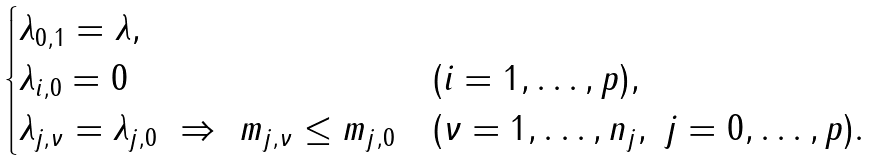Convert formula to latex. <formula><loc_0><loc_0><loc_500><loc_500>\begin{cases} \lambda _ { 0 , 1 } = \lambda , \\ \lambda _ { i , 0 } = 0 & ( i = 1 , \dots , p ) , \\ \lambda _ { j , \nu } = \lambda _ { j , 0 } \ \Rightarrow \ m _ { j , \nu } \leq m _ { j , 0 } & ( \nu = 1 , \dots , n _ { j } , \ j = 0 , \dots , p ) . \end{cases}</formula> 